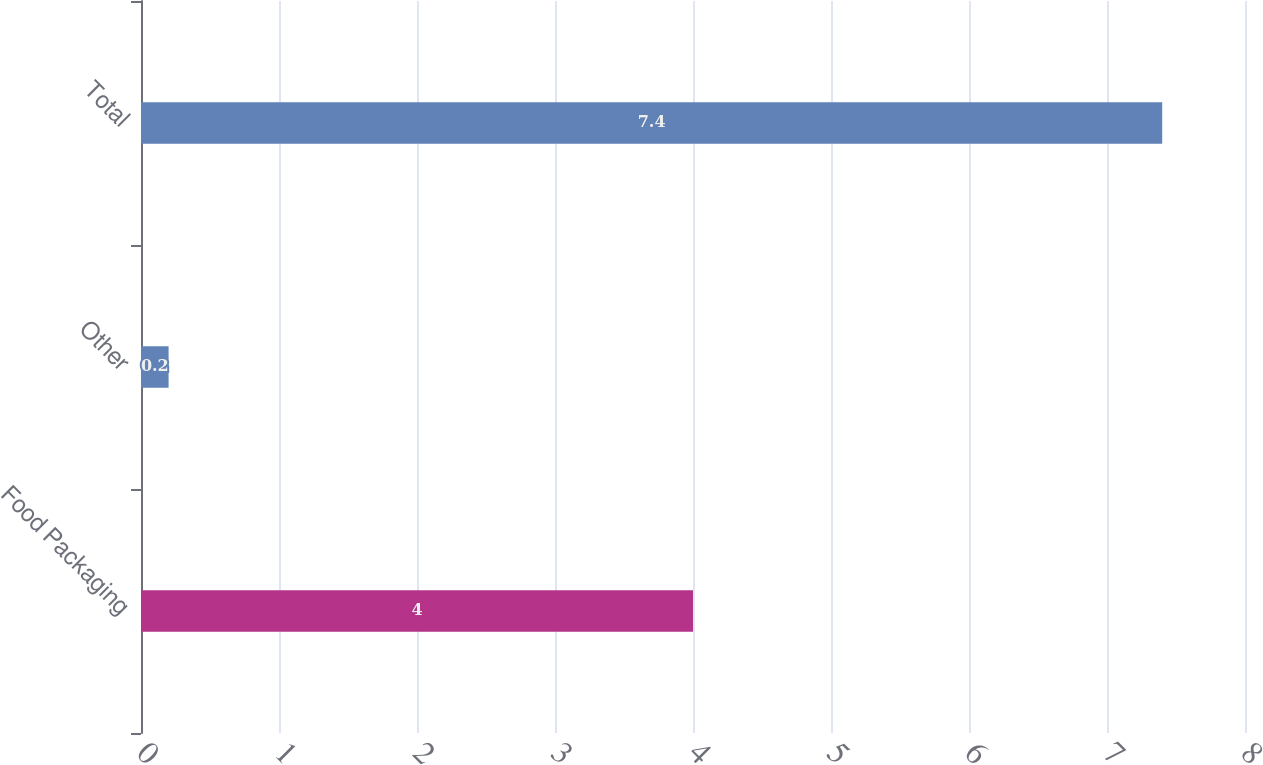<chart> <loc_0><loc_0><loc_500><loc_500><bar_chart><fcel>Food Packaging<fcel>Other<fcel>Total<nl><fcel>4<fcel>0.2<fcel>7.4<nl></chart> 